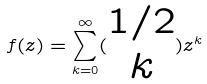<formula> <loc_0><loc_0><loc_500><loc_500>f ( z ) = \sum _ { k = 0 } ^ { \infty } ( \begin{matrix} 1 / 2 \\ k \end{matrix} ) z ^ { k }</formula> 